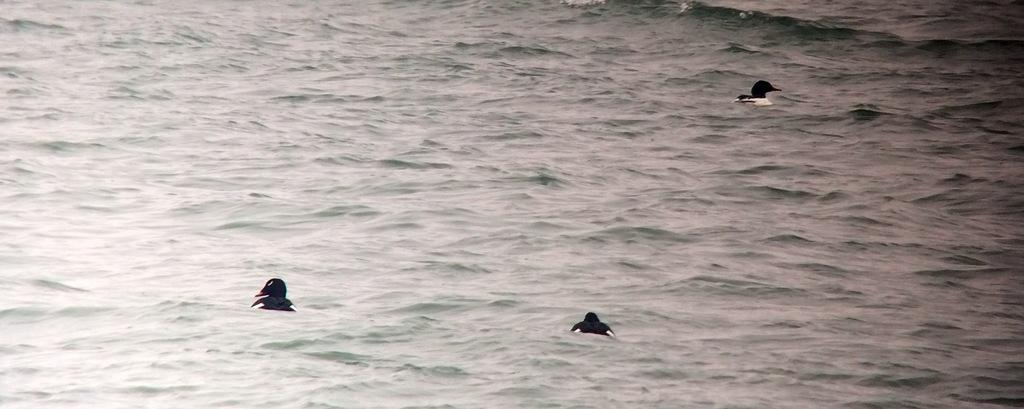How many ducks are present in the image? There are 3 ducks in the image. What are the ducks doing in the image? The ducks are swimming in the water. What color are the ducks in the image? The ducks are black in color. How many teeth can be seen on the ducks in the image? Ducks do not have teeth, so none can be seen in the image. 